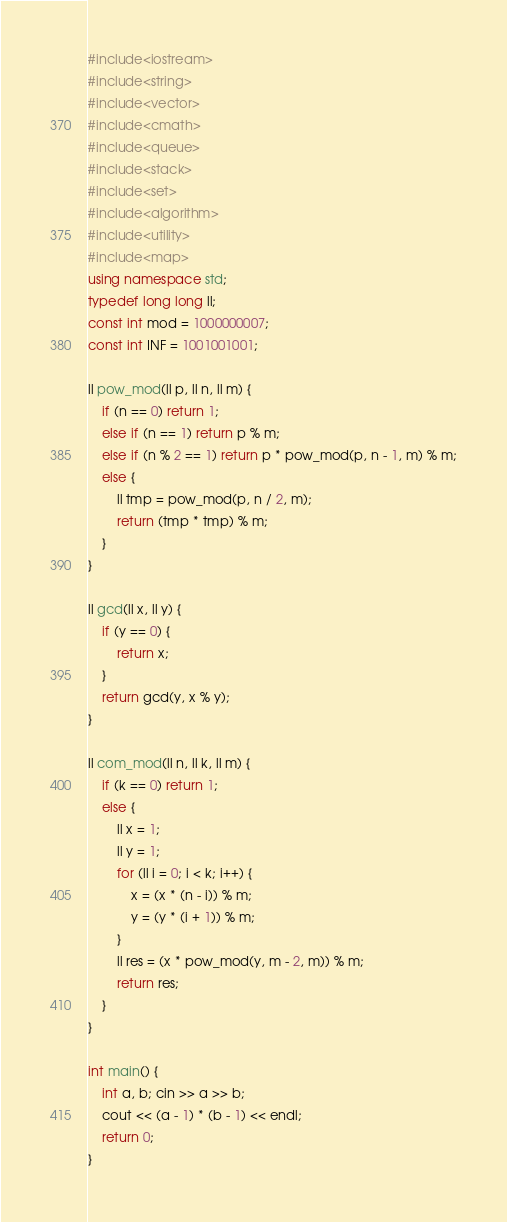Convert code to text. <code><loc_0><loc_0><loc_500><loc_500><_C++_>#include<iostream>
#include<string>
#include<vector>
#include<cmath>
#include<queue>
#include<stack>
#include<set>
#include<algorithm>
#include<utility>
#include<map>
using namespace std;
typedef long long ll;
const int mod = 1000000007;
const int INF = 1001001001;

ll pow_mod(ll p, ll n, ll m) {
	if (n == 0) return 1;
	else if (n == 1) return p % m;
	else if (n % 2 == 1) return p * pow_mod(p, n - 1, m) % m;
	else {
		ll tmp = pow_mod(p, n / 2, m);
		return (tmp * tmp) % m;
	}
}

ll gcd(ll x, ll y) {
	if (y == 0) {
		return x;
	}
	return gcd(y, x % y);
}

ll com_mod(ll n, ll k, ll m) {
	if (k == 0) return 1;
	else {
		ll x = 1;
		ll y = 1;
		for (ll i = 0; i < k; i++) {
			x = (x * (n - i)) % m;
			y = (y * (i + 1)) % m;
		}
		ll res = (x * pow_mod(y, m - 2, m)) % m;
		return res;
	}
}

int main() {
	int a, b; cin >> a >> b;
	cout << (a - 1) * (b - 1) << endl;
	return 0;
}</code> 